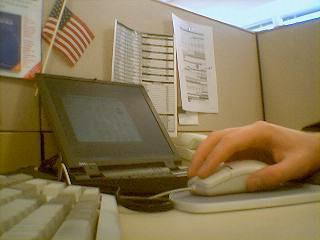Is the mouse hooked up to the laptop?
Answer briefly. Yes. Is there a reflection in the computer screen?
Concise answer only. No. Is this a work cubicle?
Give a very brief answer. Yes. How many monitors does this person have on his desk?
Answer briefly. 1. What kind of flag is that?
Give a very brief answer. American. 